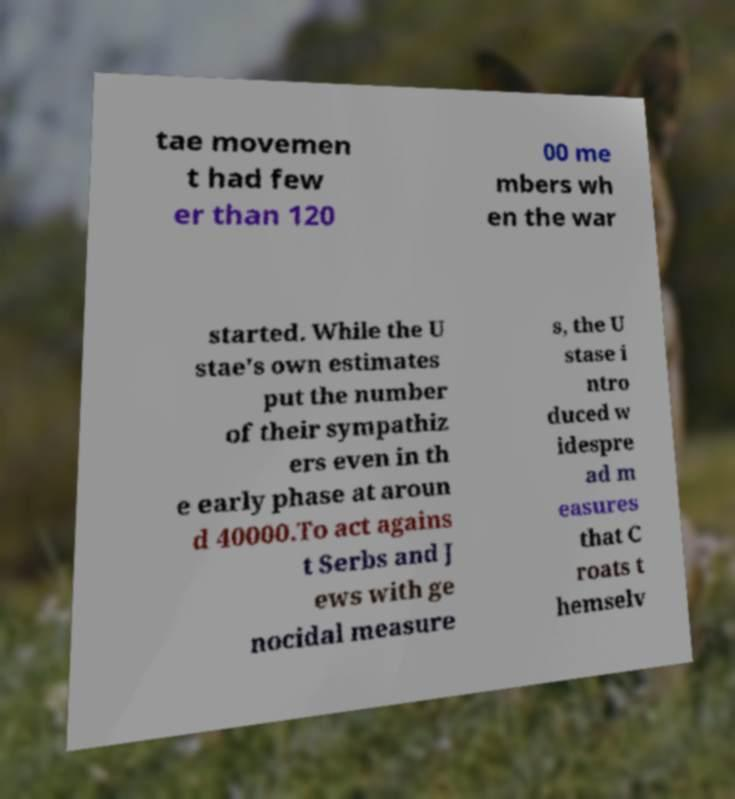Could you extract and type out the text from this image? tae movemen t had few er than 120 00 me mbers wh en the war started. While the U stae's own estimates put the number of their sympathiz ers even in th e early phase at aroun d 40000.To act agains t Serbs and J ews with ge nocidal measure s, the U stase i ntro duced w idespre ad m easures that C roats t hemselv 